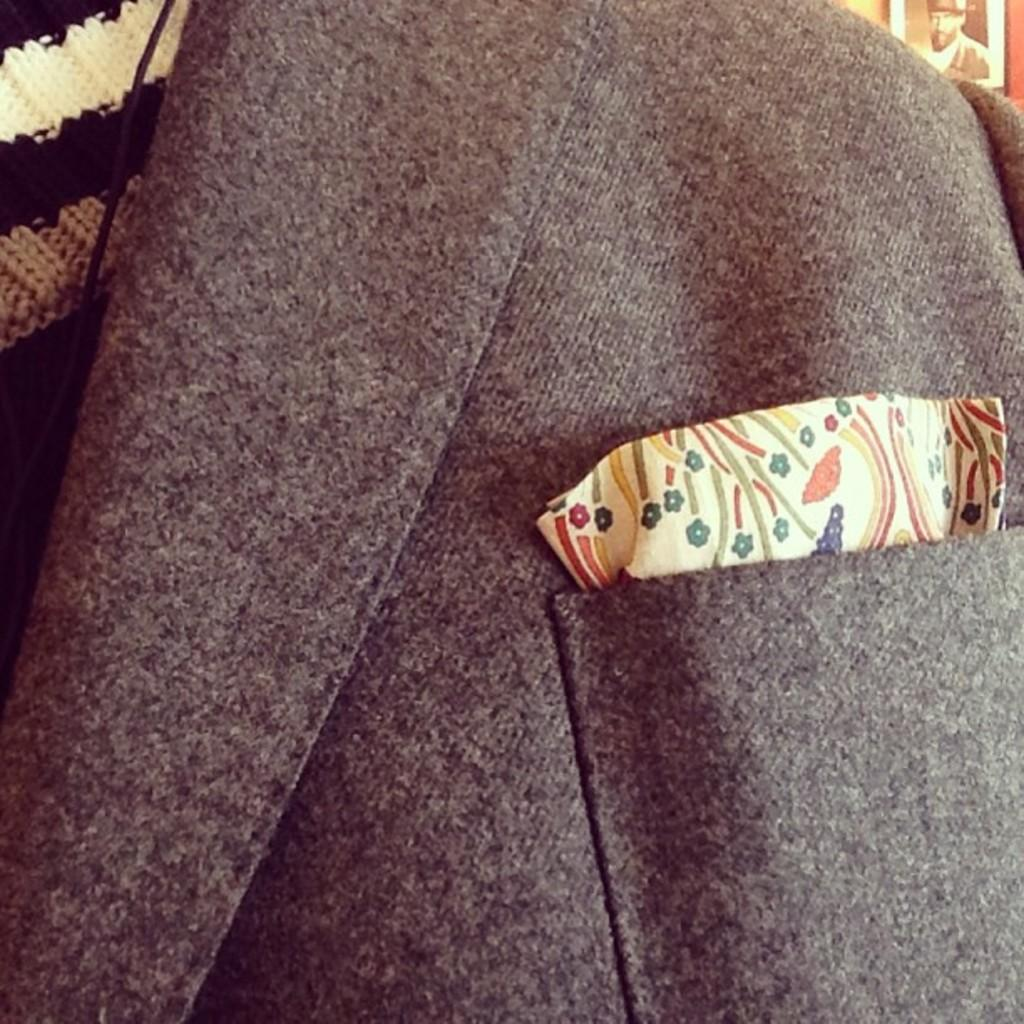What type of clothing item is in the image? There is a jacket in the image. What can be seen on the right side of the image? There is a photograph on the right side of the image. What is located on the left side of the image? There is a cloth on the left side of the image. What type of metal object is present in the image? There is no metal object present in the image. Who has the authority in the image? The concept of authority is not applicable to the objects in the image, as they are inanimate. 